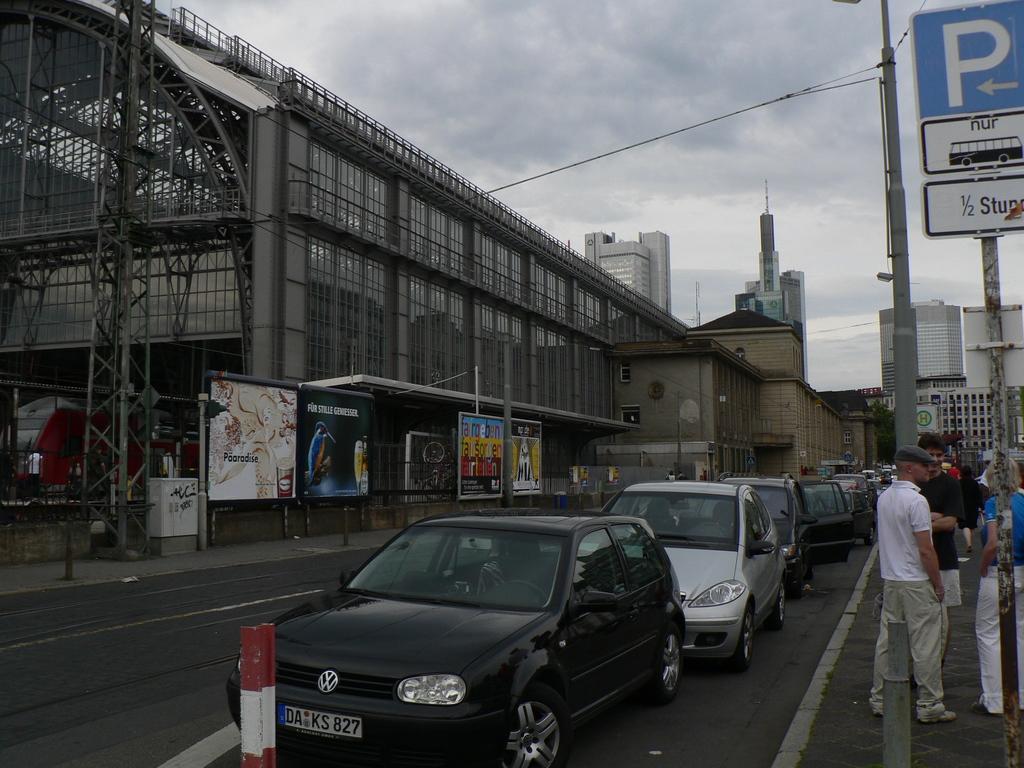Please provide a concise description of this image. In this image we can see road, cars, persons, sign boards, street lights, wires, buildings, advertisements, sky and clouds. 